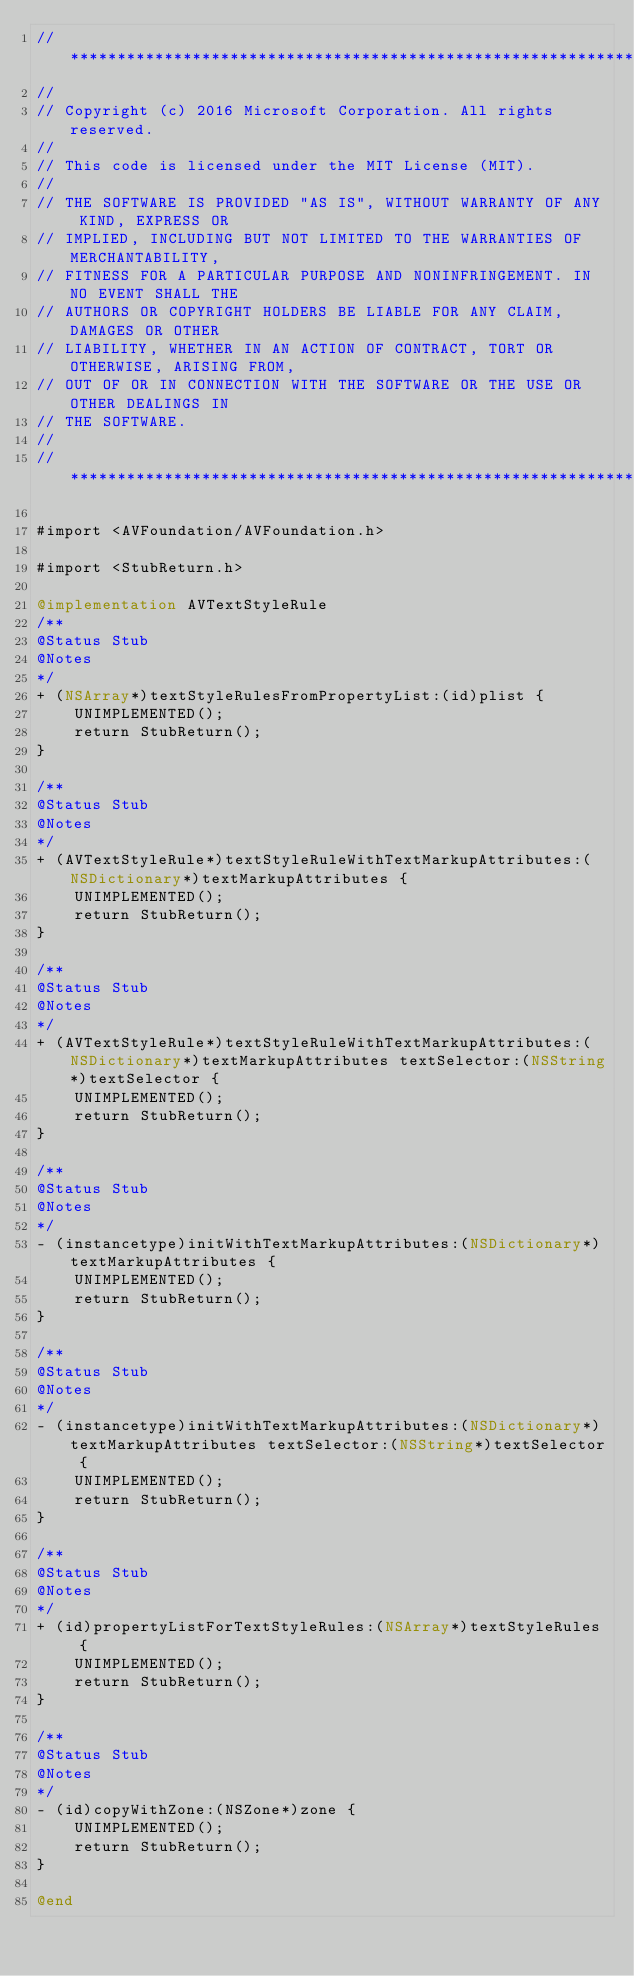Convert code to text. <code><loc_0><loc_0><loc_500><loc_500><_ObjectiveC_>//******************************************************************************
//
// Copyright (c) 2016 Microsoft Corporation. All rights reserved.
//
// This code is licensed under the MIT License (MIT).
//
// THE SOFTWARE IS PROVIDED "AS IS", WITHOUT WARRANTY OF ANY KIND, EXPRESS OR
// IMPLIED, INCLUDING BUT NOT LIMITED TO THE WARRANTIES OF MERCHANTABILITY,
// FITNESS FOR A PARTICULAR PURPOSE AND NONINFRINGEMENT. IN NO EVENT SHALL THE
// AUTHORS OR COPYRIGHT HOLDERS BE LIABLE FOR ANY CLAIM, DAMAGES OR OTHER
// LIABILITY, WHETHER IN AN ACTION OF CONTRACT, TORT OR OTHERWISE, ARISING FROM,
// OUT OF OR IN CONNECTION WITH THE SOFTWARE OR THE USE OR OTHER DEALINGS IN
// THE SOFTWARE.
//
//******************************************************************************

#import <AVFoundation/AVFoundation.h>

#import <StubReturn.h>

@implementation AVTextStyleRule
/**
@Status Stub
@Notes
*/
+ (NSArray*)textStyleRulesFromPropertyList:(id)plist {
    UNIMPLEMENTED();
    return StubReturn();
}

/**
@Status Stub
@Notes
*/
+ (AVTextStyleRule*)textStyleRuleWithTextMarkupAttributes:(NSDictionary*)textMarkupAttributes {
    UNIMPLEMENTED();
    return StubReturn();
}

/**
@Status Stub
@Notes
*/
+ (AVTextStyleRule*)textStyleRuleWithTextMarkupAttributes:(NSDictionary*)textMarkupAttributes textSelector:(NSString*)textSelector {
    UNIMPLEMENTED();
    return StubReturn();
}

/**
@Status Stub
@Notes
*/
- (instancetype)initWithTextMarkupAttributes:(NSDictionary*)textMarkupAttributes {
    UNIMPLEMENTED();
    return StubReturn();
}

/**
@Status Stub
@Notes
*/
- (instancetype)initWithTextMarkupAttributes:(NSDictionary*)textMarkupAttributes textSelector:(NSString*)textSelector {
    UNIMPLEMENTED();
    return StubReturn();
}

/**
@Status Stub
@Notes
*/
+ (id)propertyListForTextStyleRules:(NSArray*)textStyleRules {
    UNIMPLEMENTED();
    return StubReturn();
}

/**
@Status Stub
@Notes
*/
- (id)copyWithZone:(NSZone*)zone {
    UNIMPLEMENTED();
    return StubReturn();
}

@end
</code> 